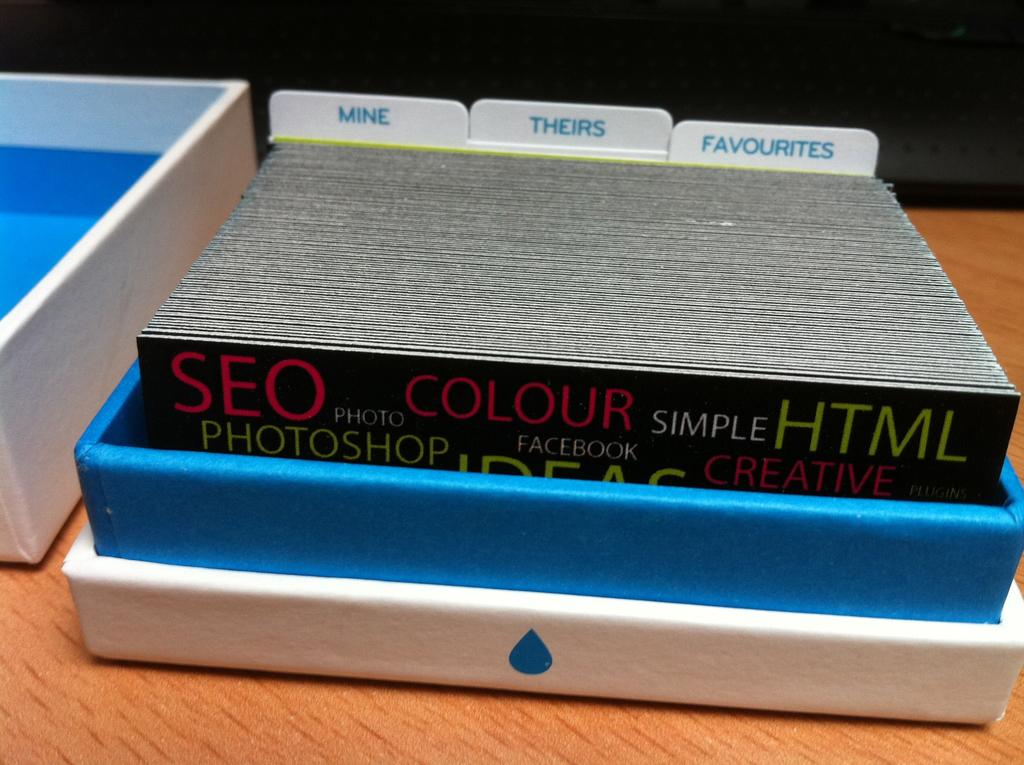Provide a one-sentence caption for the provided image. A shallow box contains tabs for mine, theirs and favorites. 